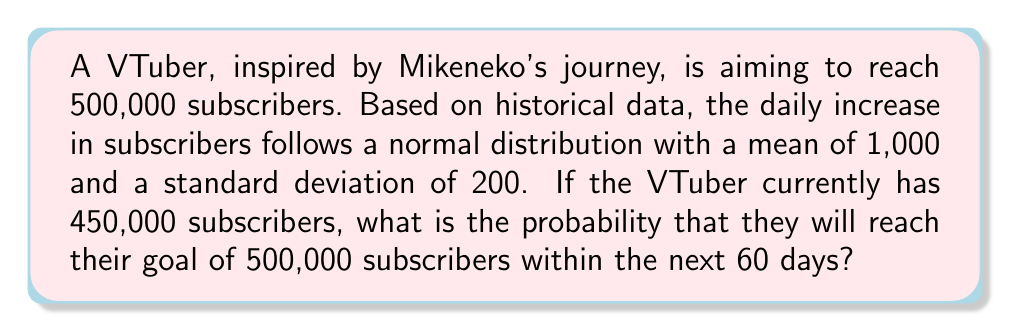Help me with this question. Let's approach this step-by-step:

1) First, we need to determine how many subscribers the VTuber needs to gain:
   $500,000 - 450,000 = 50,000$ subscribers

2) We're told that the daily increase follows a normal distribution with:
   $\mu = 1,000$ and $\sigma = 200$

3) Over 60 days, the total increase in subscribers will also follow a normal distribution with:
   $\mu_{60} = 60 \times 1,000 = 60,000$
   $\sigma_{60} = \sqrt{60} \times 200 = 1,549.19$ (using the property that variances add for independent random variables)

4) We want to find the probability that this 60-day increase is at least 50,000.

5) We can standardize this using the Z-score formula:
   $$Z = \frac{X - \mu}{\sigma} = \frac{50,000 - 60,000}{1,549.19} = -6.45$$

6) We're looking for $P(X \geq 50,000)$, which is equivalent to $P(Z \geq -6.45)$

7) Using a standard normal table or calculator, we can find:
   $P(Z \geq -6.45) \approx 0.9999999999$

Therefore, the probability of reaching 500,000 subscribers within 60 days is approximately 0.9999999999 or 99.99999999%.
Answer: $0.9999999999$ or $99.99999999\%$ 